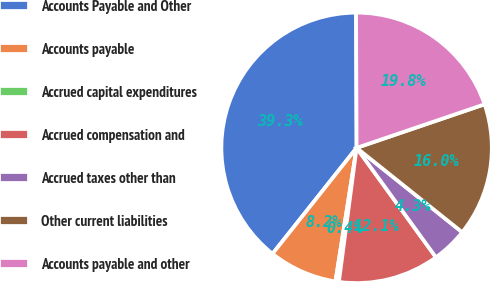Convert chart. <chart><loc_0><loc_0><loc_500><loc_500><pie_chart><fcel>Accounts Payable and Other<fcel>Accounts payable<fcel>Accrued capital expenditures<fcel>Accrued compensation and<fcel>Accrued taxes other than<fcel>Other current liabilities<fcel>Accounts payable and other<nl><fcel>39.26%<fcel>8.18%<fcel>0.41%<fcel>12.07%<fcel>4.29%<fcel>15.95%<fcel>19.84%<nl></chart> 